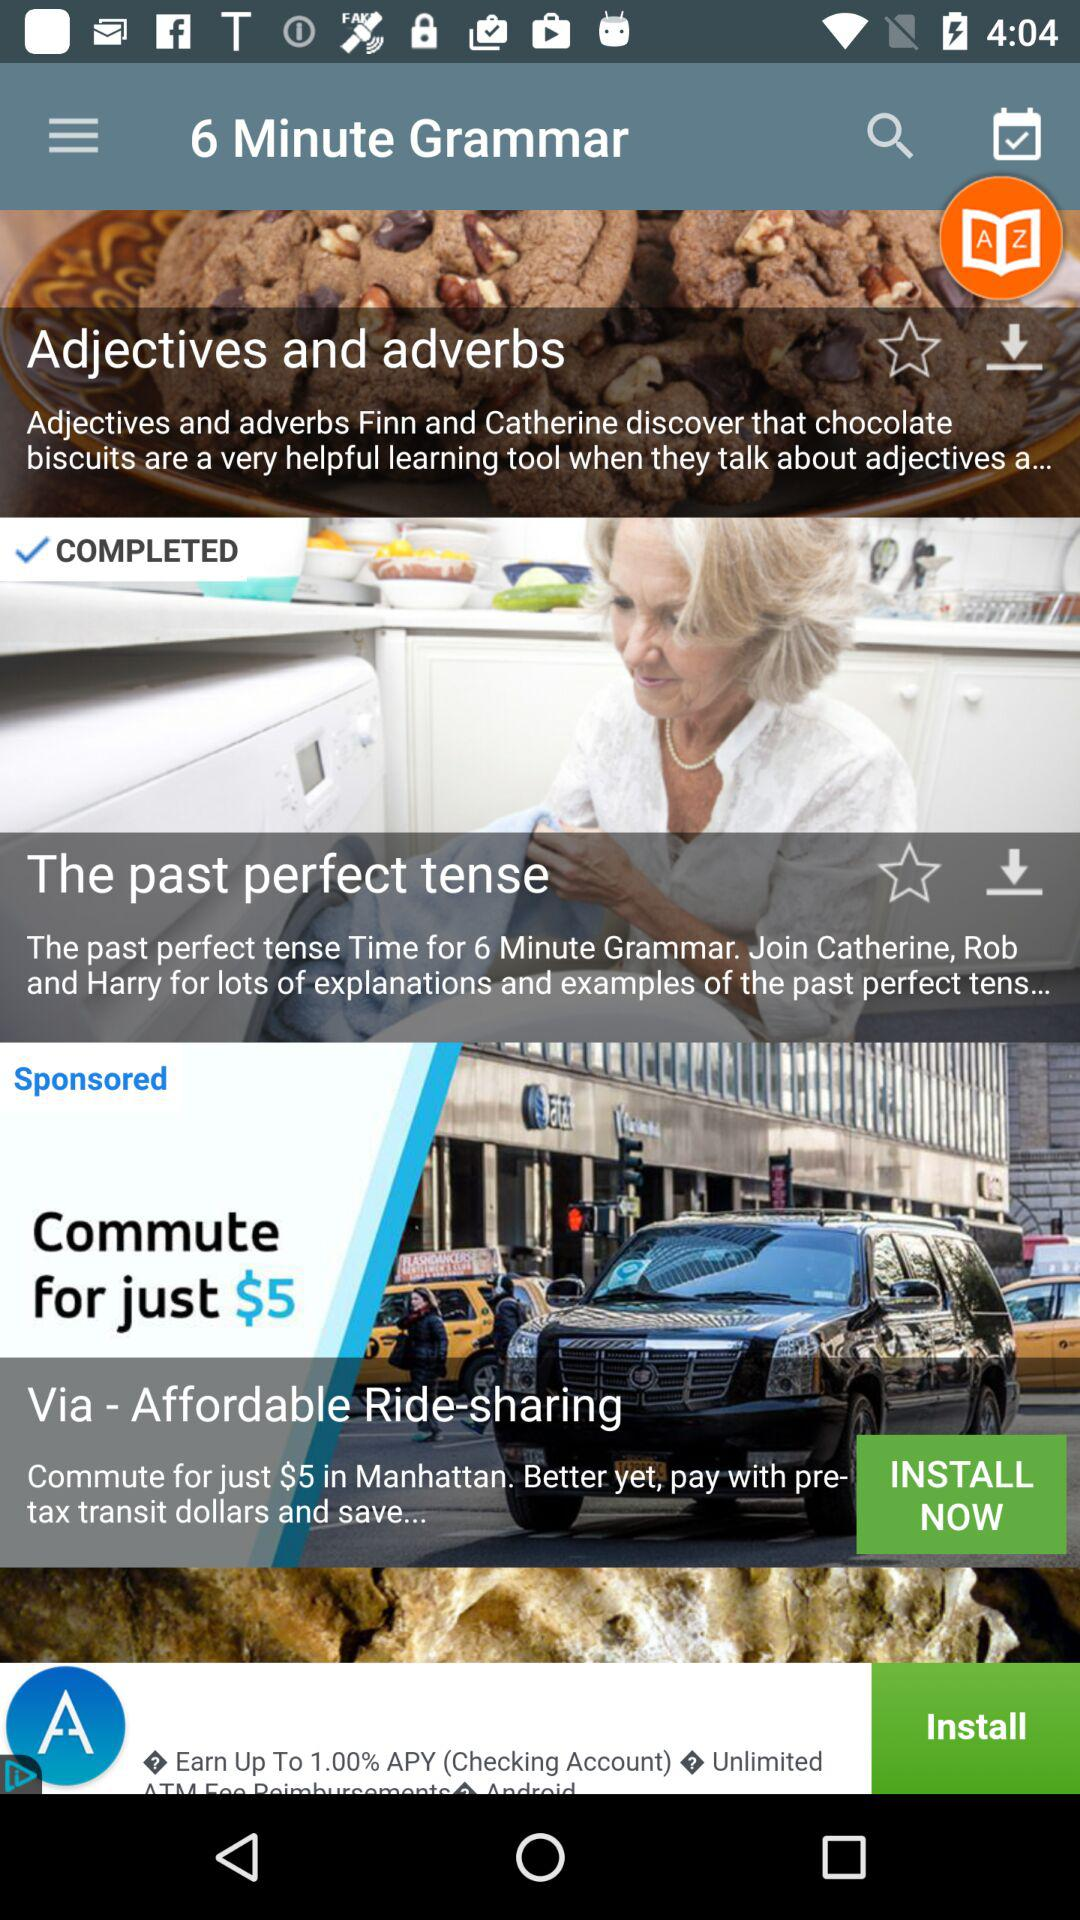What are the various parts of the 6 minute grammar? The various parts of 6 minute grammar are "Adjectives and adverbs" and "The past perfect tense". 